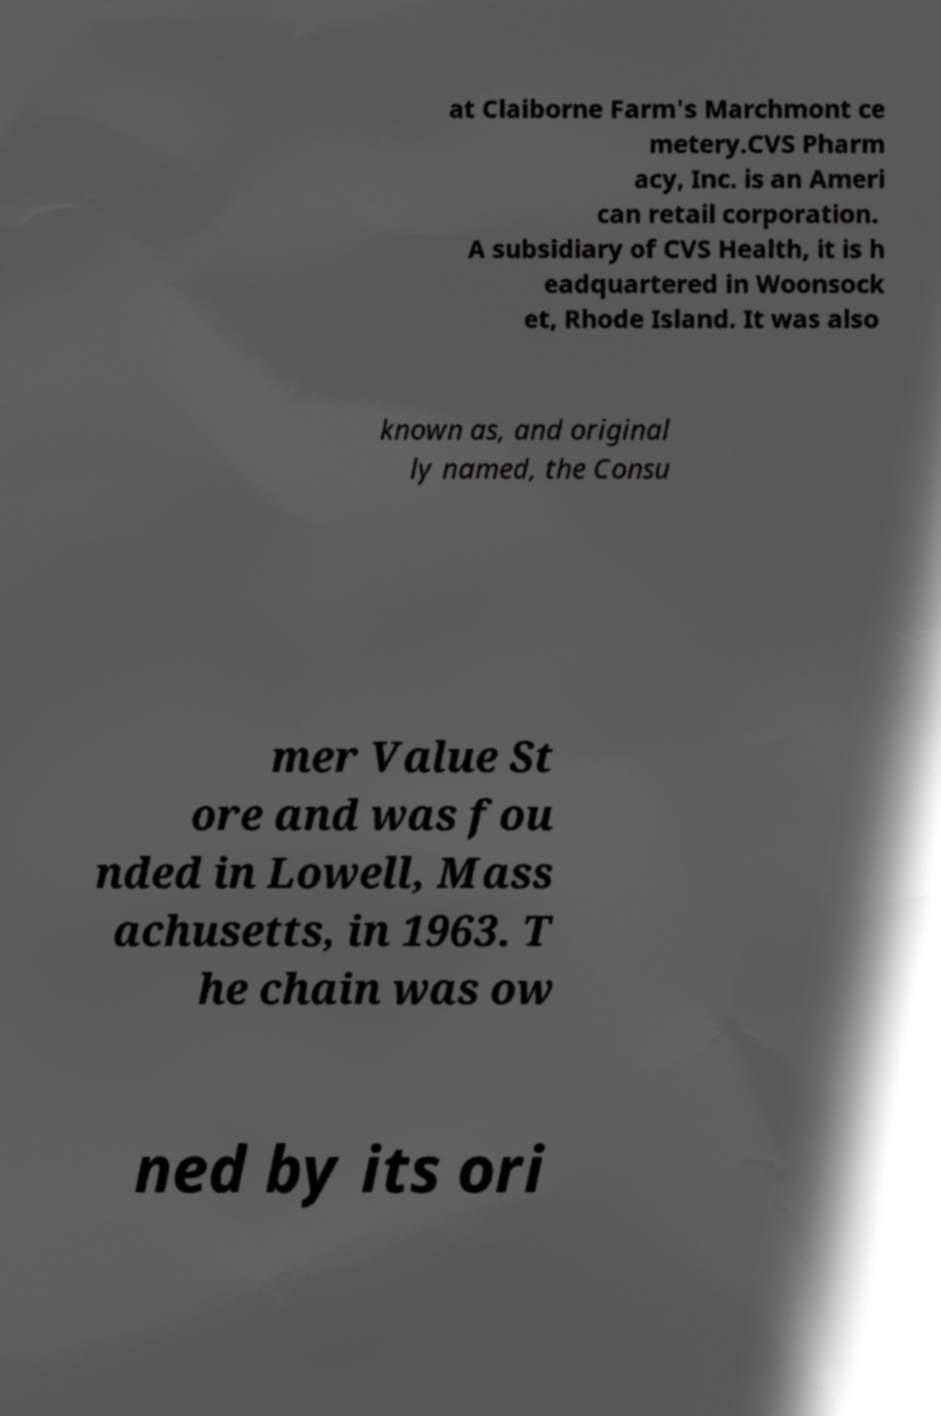Can you read and provide the text displayed in the image?This photo seems to have some interesting text. Can you extract and type it out for me? at Claiborne Farm's Marchmont ce metery.CVS Pharm acy, Inc. is an Ameri can retail corporation. A subsidiary of CVS Health, it is h eadquartered in Woonsock et, Rhode Island. It was also known as, and original ly named, the Consu mer Value St ore and was fou nded in Lowell, Mass achusetts, in 1963. T he chain was ow ned by its ori 